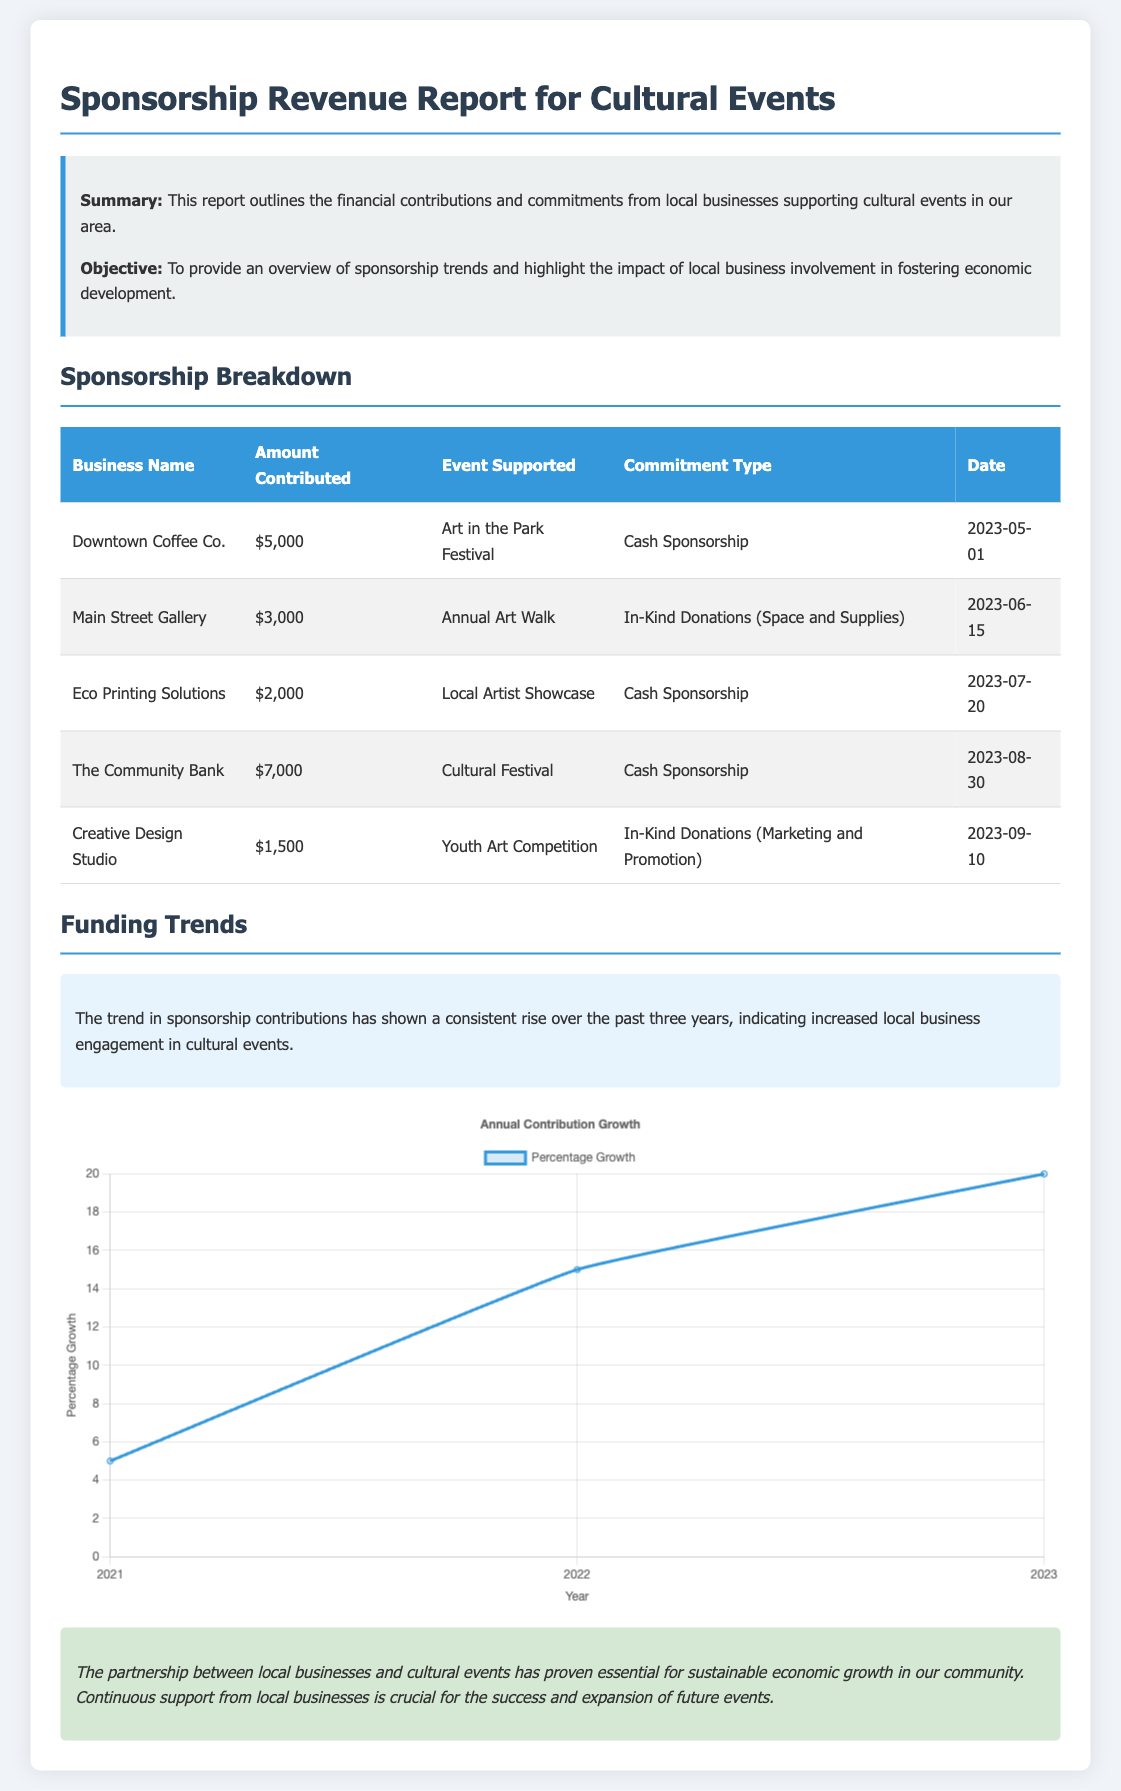What is the total contribution from The Community Bank? The total contribution is only specified for The Community Bank in the table, which states $7,000.
Answer: $7,000 How much did Eco Printing Solutions contribute? The amount contributed by Eco Printing Solutions is specified in the table as $2,000.
Answer: $2,000 What event did Main Street Gallery support? The event supported by Main Street Gallery is listed in the table as the Annual Art Walk.
Answer: Annual Art Walk What type of sponsorship did Downtown Coffee Co. provide? The type of sponsorship from Downtown Coffee Co. is defined in the table as Cash Sponsorship.
Answer: Cash Sponsorship What is the percentage growth for 2023? The document states the percentage growth for 2023 as part of the trend analysis, which is 20%.
Answer: 20% Which year shows the highest contribution growth percentage? By examining the percentage growth data, 2023 shows the highest contribution growth percentage at 20%.
Answer: 2023 What does the trend analysis indicate about sponsorship contributions? The trend analysis indicates a consistent rise in sponsorship contributions over the past three years.
Answer: Consistent rise How many businesses contributed to the report? The report lists five businesses that contributed, as shown in the table.
Answer: Five businesses What is the main objective of the report? The main objective of the report is summarized in the document as providing an overview of sponsorship trends and highlighting local business involvement.
Answer: Overview of sponsorship trends 